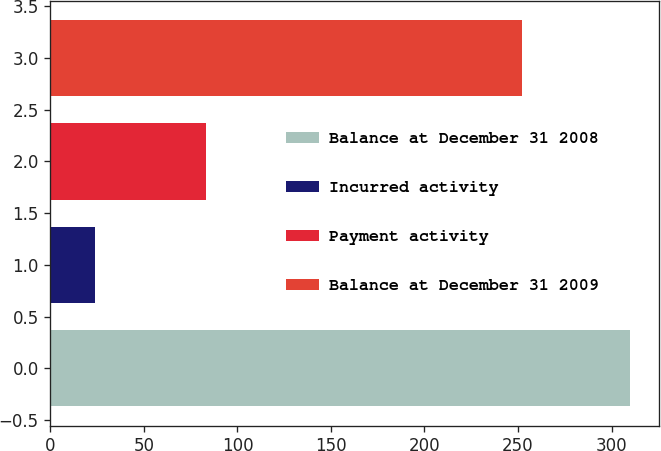Convert chart to OTSL. <chart><loc_0><loc_0><loc_500><loc_500><bar_chart><fcel>Balance at December 31 2008<fcel>Incurred activity<fcel>Payment activity<fcel>Balance at December 31 2009<nl><fcel>310<fcel>24<fcel>83<fcel>252<nl></chart> 